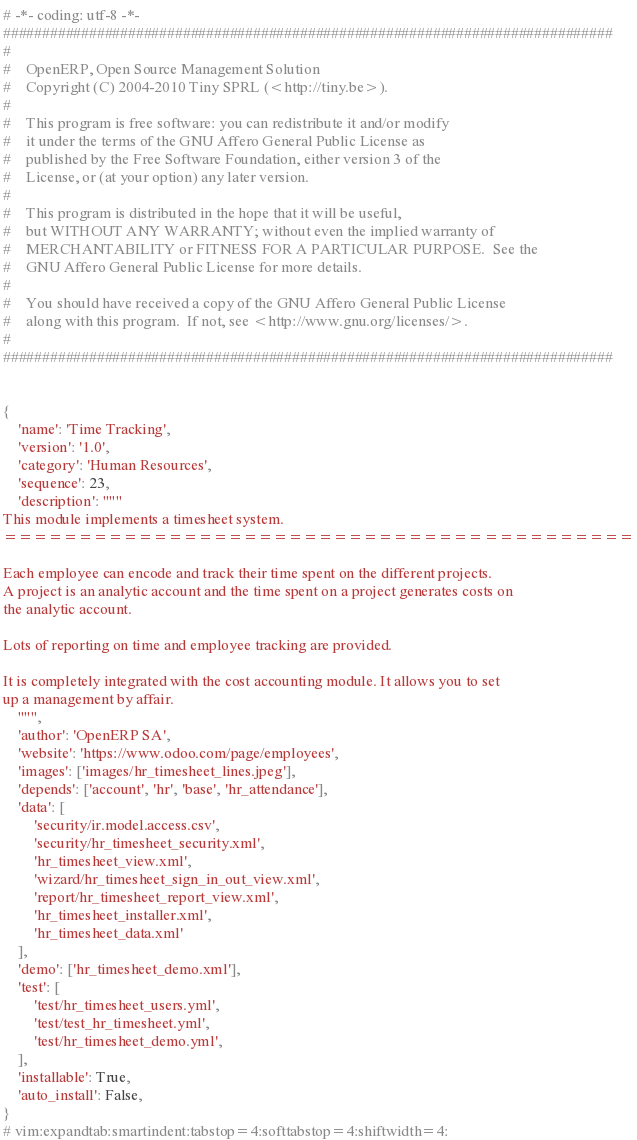<code> <loc_0><loc_0><loc_500><loc_500><_Python_># -*- coding: utf-8 -*-
##############################################################################
#
#    OpenERP, Open Source Management Solution
#    Copyright (C) 2004-2010 Tiny SPRL (<http://tiny.be>).
#
#    This program is free software: you can redistribute it and/or modify
#    it under the terms of the GNU Affero General Public License as
#    published by the Free Software Foundation, either version 3 of the
#    License, or (at your option) any later version.
#
#    This program is distributed in the hope that it will be useful,
#    but WITHOUT ANY WARRANTY; without even the implied warranty of
#    MERCHANTABILITY or FITNESS FOR A PARTICULAR PURPOSE.  See the
#    GNU Affero General Public License for more details.
#
#    You should have received a copy of the GNU Affero General Public License
#    along with this program.  If not, see <http://www.gnu.org/licenses/>.
#
##############################################################################


{
    'name': 'Time Tracking',
    'version': '1.0',
    'category': 'Human Resources',
    'sequence': 23,
    'description': """
This module implements a timesheet system.
==========================================

Each employee can encode and track their time spent on the different projects.
A project is an analytic account and the time spent on a project generates costs on
the analytic account.

Lots of reporting on time and employee tracking are provided.

It is completely integrated with the cost accounting module. It allows you to set
up a management by affair.
    """,
    'author': 'OpenERP SA',
    'website': 'https://www.odoo.com/page/employees',
    'images': ['images/hr_timesheet_lines.jpeg'],
    'depends': ['account', 'hr', 'base', 'hr_attendance'],
    'data': [
        'security/ir.model.access.csv',
        'security/hr_timesheet_security.xml',
        'hr_timesheet_view.xml',
        'wizard/hr_timesheet_sign_in_out_view.xml',
        'report/hr_timesheet_report_view.xml',
        'hr_timesheet_installer.xml',
        'hr_timesheet_data.xml'
    ],
    'demo': ['hr_timesheet_demo.xml'],
    'test': [
        'test/hr_timesheet_users.yml',
        'test/test_hr_timesheet.yml',
        'test/hr_timesheet_demo.yml',
    ],
    'installable': True,
    'auto_install': False,
}
# vim:expandtab:smartindent:tabstop=4:softtabstop=4:shiftwidth=4:
</code> 